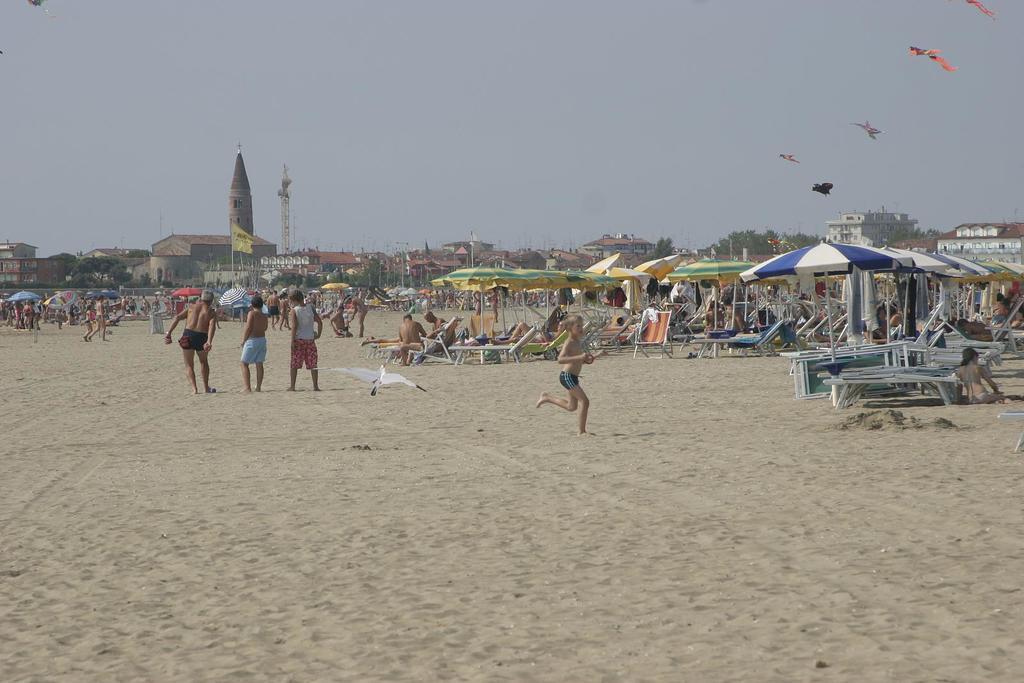Can you describe this image briefly? In this image there are a few people standing, walking and running on the sand and there are a few other people sitting on chairs under the tents on the sand, in the background of the image there are buildings. 